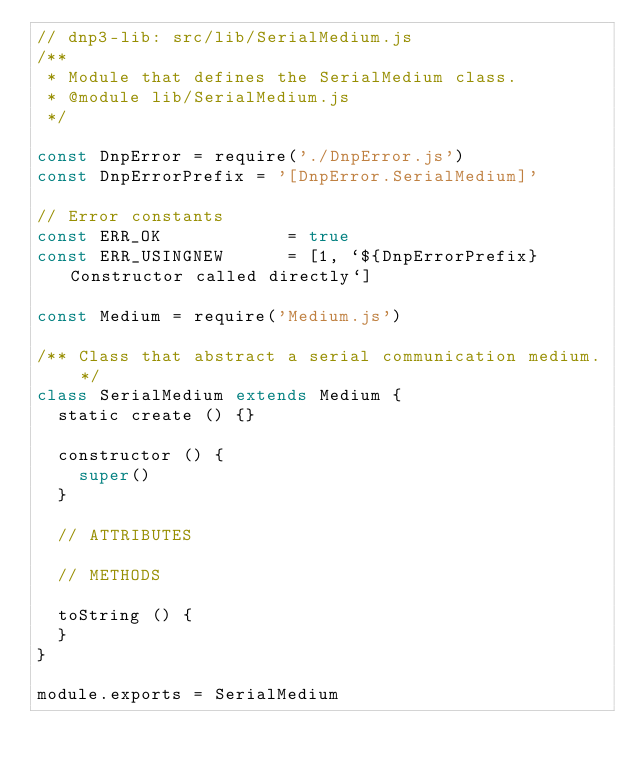Convert code to text. <code><loc_0><loc_0><loc_500><loc_500><_JavaScript_>// dnp3-lib: src/lib/SerialMedium.js
/**
 * Module that defines the SerialMedium class.
 * @module lib/SerialMedium.js
 */

const DnpError = require('./DnpError.js')
const DnpErrorPrefix = '[DnpError.SerialMedium]'

// Error constants
const ERR_OK            = true
const ERR_USINGNEW      = [1, `${DnpErrorPrefix} Constructor called directly`]

const Medium = require('Medium.js')

/** Class that abstract a serial communication medium. */
class SerialMedium extends Medium {
  static create () {}

  constructor () {
    super()
  }

  // ATTRIBUTES

  // METHODS

  toString () {
  }
}

module.exports = SerialMedium

</code> 